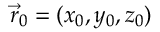<formula> <loc_0><loc_0><loc_500><loc_500>\vec { r } _ { 0 } = ( x _ { 0 } , y _ { 0 } , z _ { 0 } )</formula> 